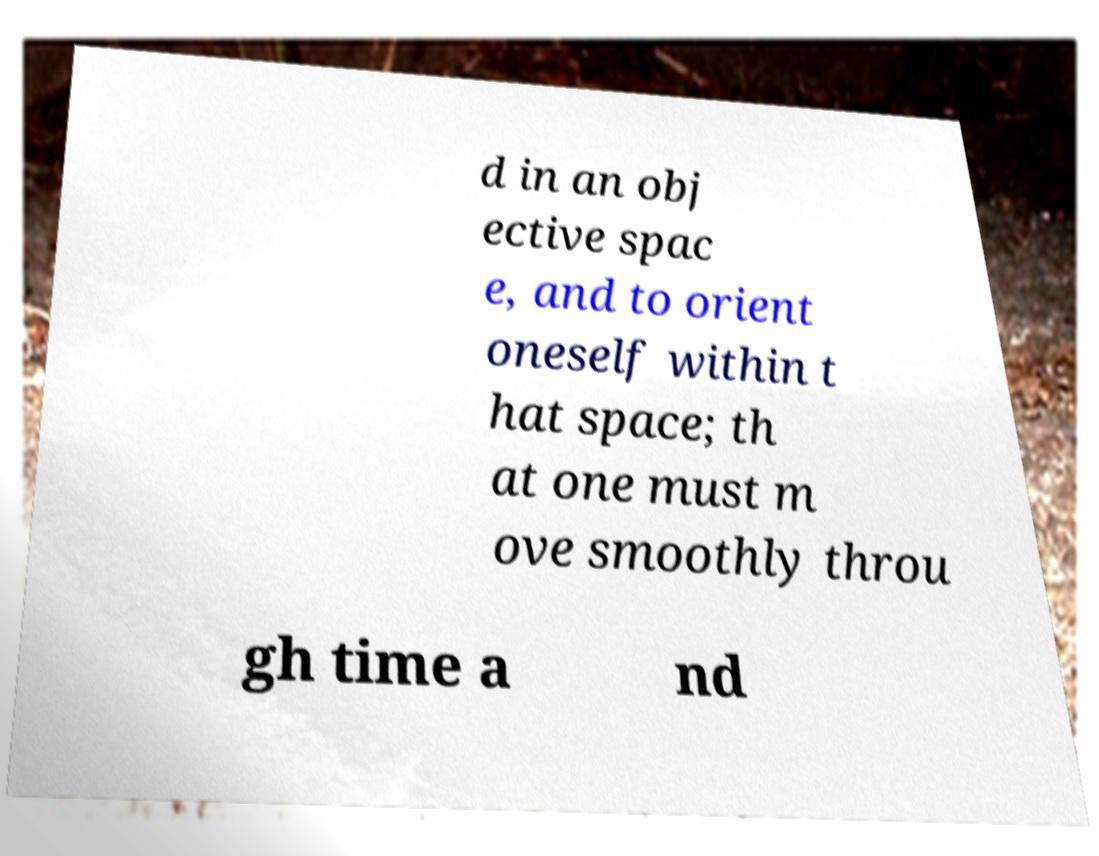I need the written content from this picture converted into text. Can you do that? d in an obj ective spac e, and to orient oneself within t hat space; th at one must m ove smoothly throu gh time a nd 